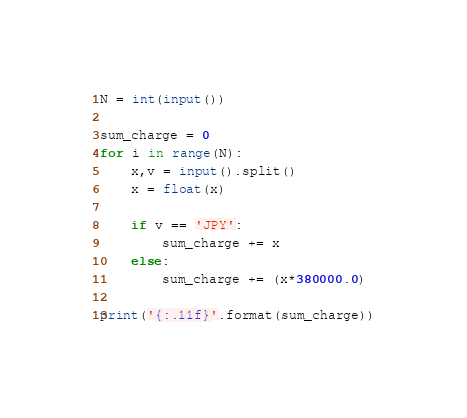Convert code to text. <code><loc_0><loc_0><loc_500><loc_500><_Python_>N = int(input())

sum_charge = 0
for i in range(N):
    x,v = input().split()
    x = float(x)

    if v == 'JPY':
        sum_charge += x
    else:
        sum_charge += (x*380000.0)

print('{:.11f}'.format(sum_charge))
</code> 